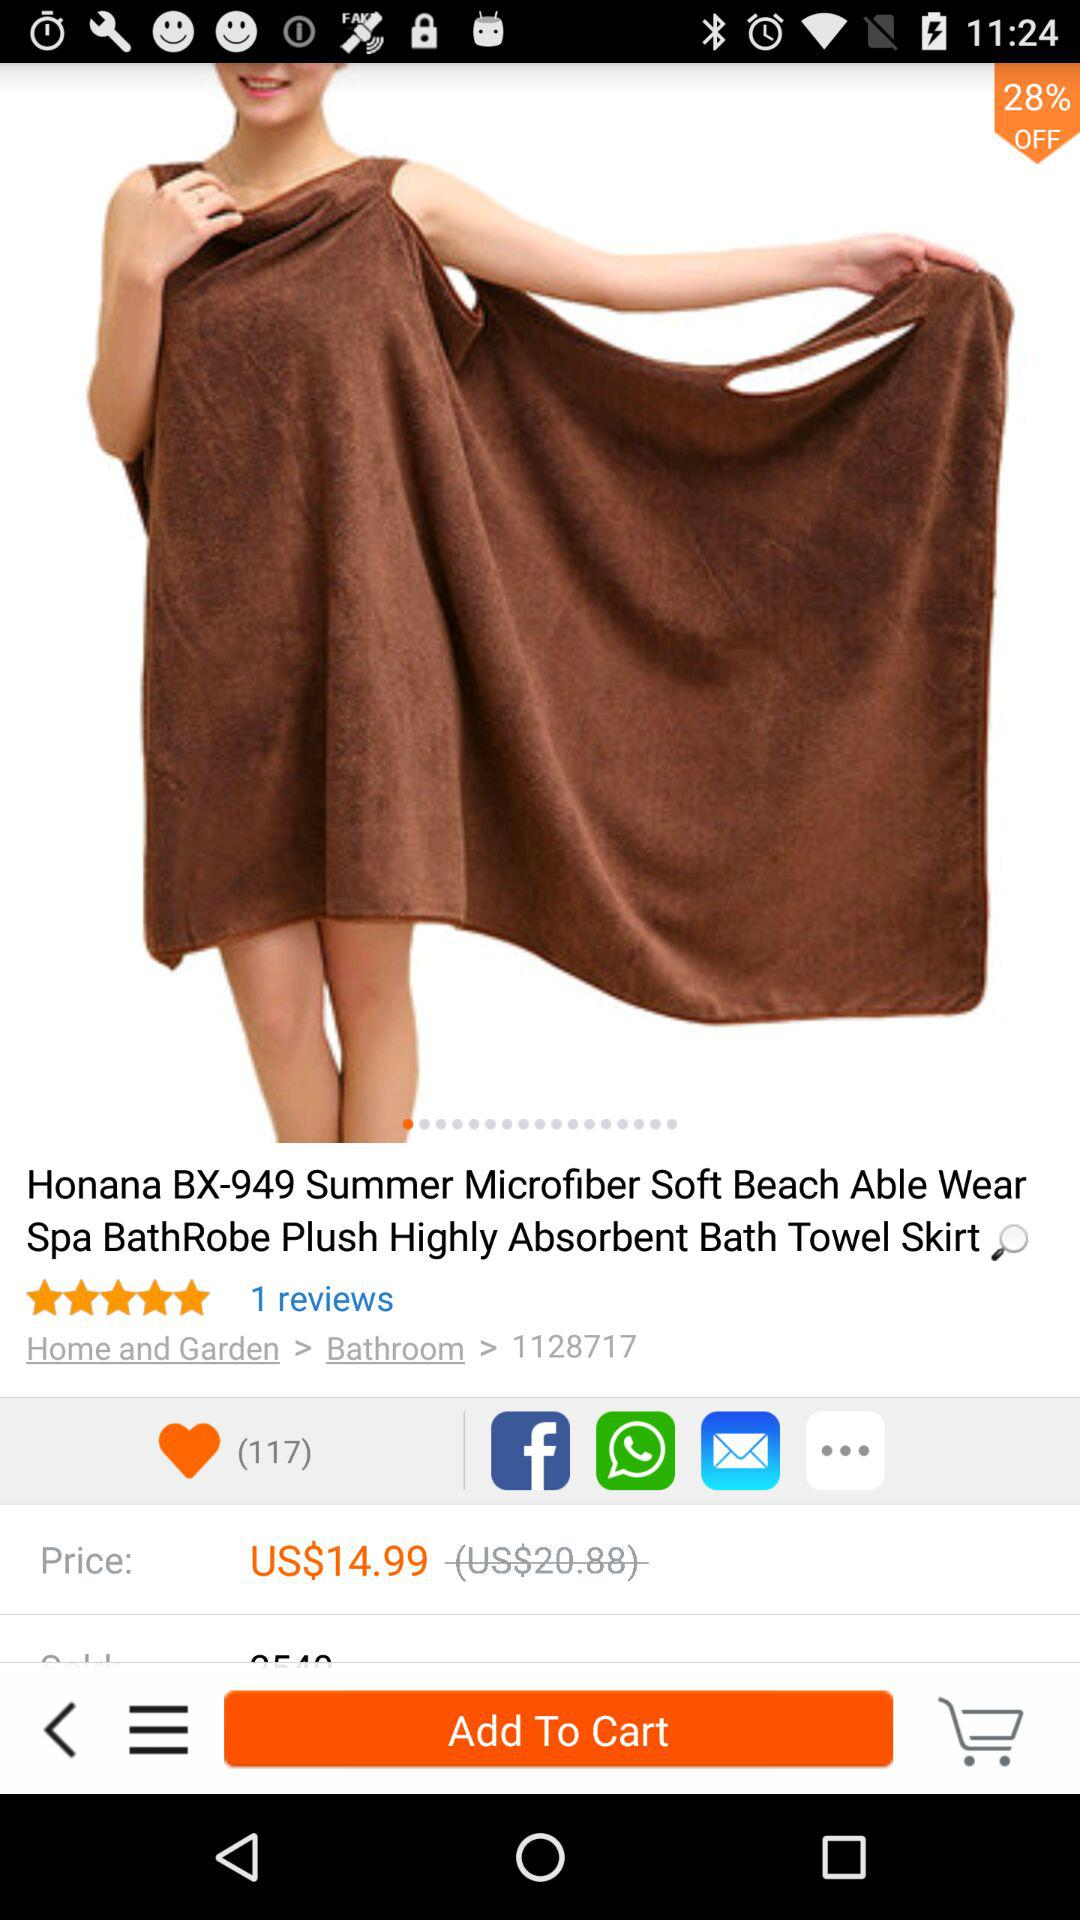What's the price of the product before the offer? The price of the product before the offer is US$20.88. 